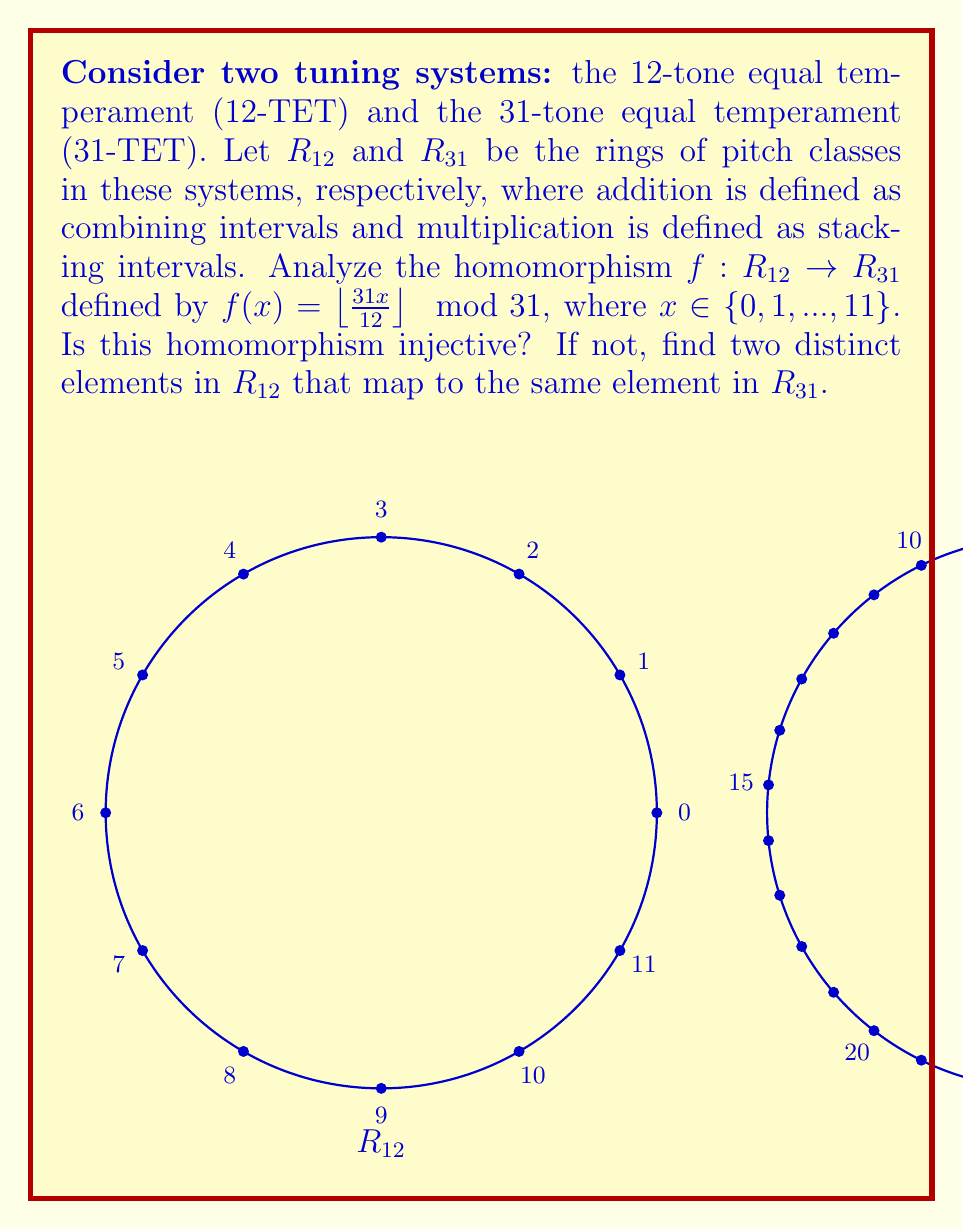Can you answer this question? To analyze this homomorphism, we need to check if it preserves the ring structure and if it's injective. Let's approach this step-by-step:

1) First, let's calculate the image of each element in $R_{12}$ under $f$:

   $f(0) = \lfloor \frac{31 \cdot 0}{12} \rfloor \mod 31 = 0$
   $f(1) = \lfloor \frac{31 \cdot 1}{12} \rfloor \mod 31 = 2$
   $f(2) = \lfloor \frac{31 \cdot 2}{12} \rfloor \mod 31 = 5$
   $f(3) = \lfloor \frac{31 \cdot 3}{12} \rfloor \mod 31 = 7$
   $f(4) = \lfloor \frac{31 \cdot 4}{12} \rfloor \mod 31 = 10$
   $f(5) = \lfloor \frac{31 \cdot 5}{12} \rfloor \mod 31 = 12$
   $f(6) = \lfloor \frac{31 \cdot 6}{12} \rfloor \mod 31 = 15$
   $f(7) = \lfloor \frac{31 \cdot 7}{12} \rfloor \mod 31 = 18$
   $f(8) = \lfloor \frac{31 \cdot 8}{12} \rfloor \mod 31 = 20$
   $f(9) = \lfloor \frac{31 \cdot 9}{12} \rfloor \mod 31 = 23$
   $f(10) = \lfloor \frac{31 \cdot 10}{12} \rfloor \mod 31 = 25$
   $f(11) = \lfloor \frac{31 \cdot 11}{12} \rfloor \mod 31 = 28$

2) To check if $f$ is injective, we need to see if there are any duplicate values in the image. From the calculations above, we can see that all values are unique. Therefore, $f$ is injective.

3) However, to fully answer the question, we need to verify if $f$ is indeed a homomorphism. For $f$ to be a ring homomorphism, it must preserve both addition and multiplication:

   For addition: $f(a + b) = f(a) + f(b)$ for all $a, b \in R_{12}$
   For multiplication: $f(a \cdot b) = f(a) \cdot f(b)$ for all $a, b \in R_{12}$

4) Let's check addition for $a = 4$ and $b = 9$:
   
   $f(4 + 9) = f(1) = 2$
   $f(4) + f(9) = 10 + 23 = 33 \equiv 2 \pmod{31}$

   This checks out for one case, but a full proof would require checking all possible combinations.

5) For multiplication, let's check $a = 3$ and $b = 4$:

   $f(3 \cdot 4) = f(0) = 0$
   $f(3) \cdot f(4) = 7 \cdot 10 = 70 \equiv 8 \pmod{31}$

   This doesn't match, which means $f$ is not a ring homomorphism.

Therefore, while the function $f$ is injective, it is not a valid ring homomorphism as it doesn't preserve multiplication.
Answer: $f$ is injective but not a ring homomorphism. 